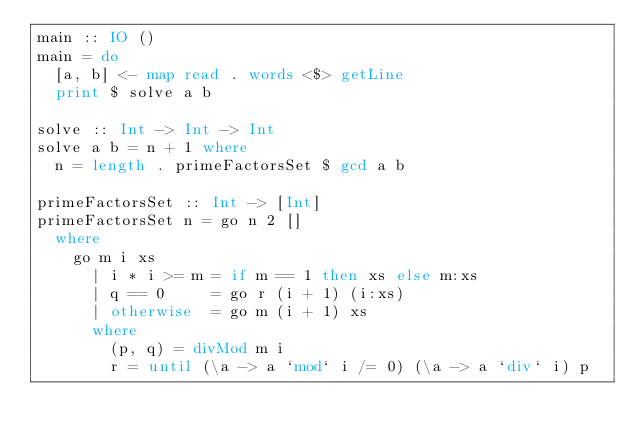<code> <loc_0><loc_0><loc_500><loc_500><_Haskell_>main :: IO ()
main = do
  [a, b] <- map read . words <$> getLine
  print $ solve a b

solve :: Int -> Int -> Int
solve a b = n + 1 where
  n = length . primeFactorsSet $ gcd a b

primeFactorsSet :: Int -> [Int]
primeFactorsSet n = go n 2 []
  where
    go m i xs
      | i * i >= m = if m == 1 then xs else m:xs
      | q == 0     = go r (i + 1) (i:xs)
      | otherwise  = go m (i + 1) xs
      where
        (p, q) = divMod m i
        r = until (\a -> a `mod` i /= 0) (\a -> a `div` i) p
</code> 